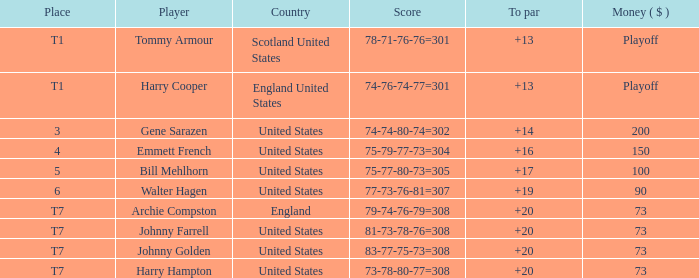When the sum is $200, where does the united states rank? 3.0. 